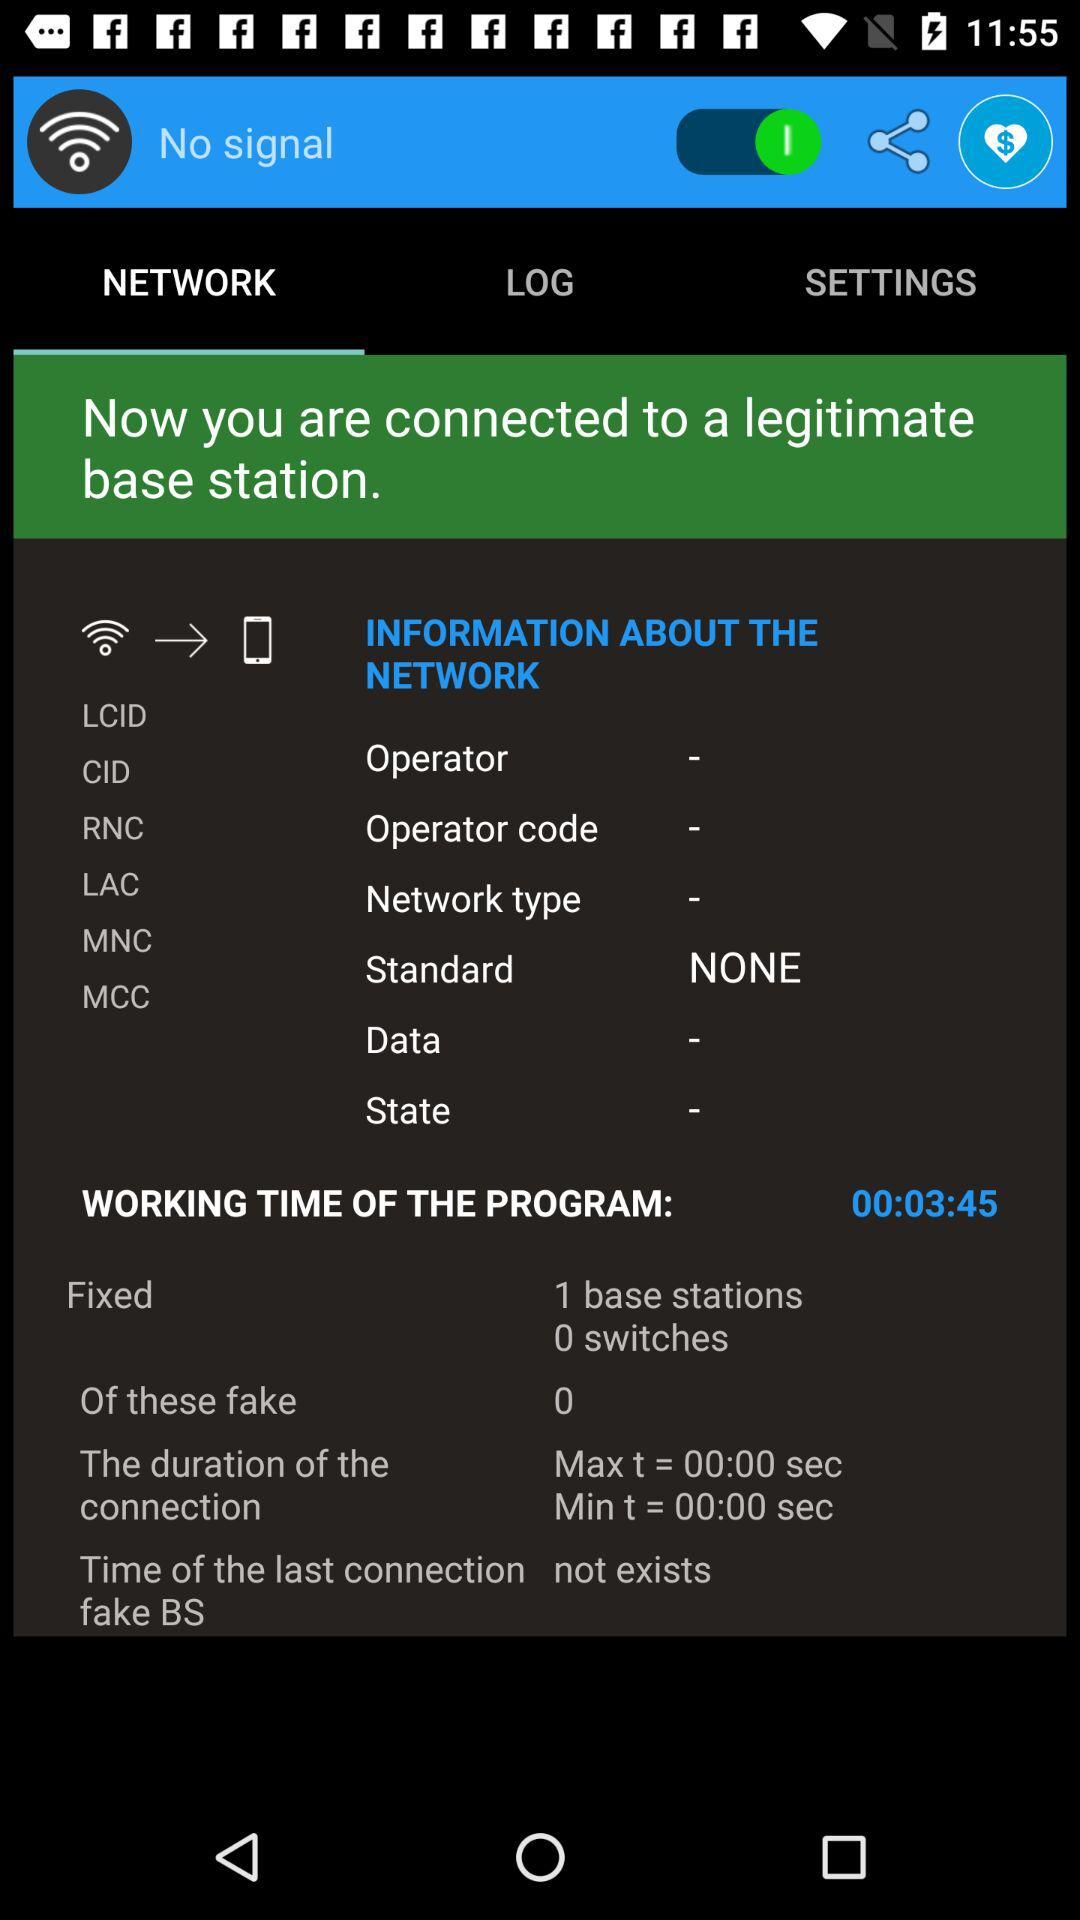What is the working time of the program? The working time of the program is 00:03:45. 